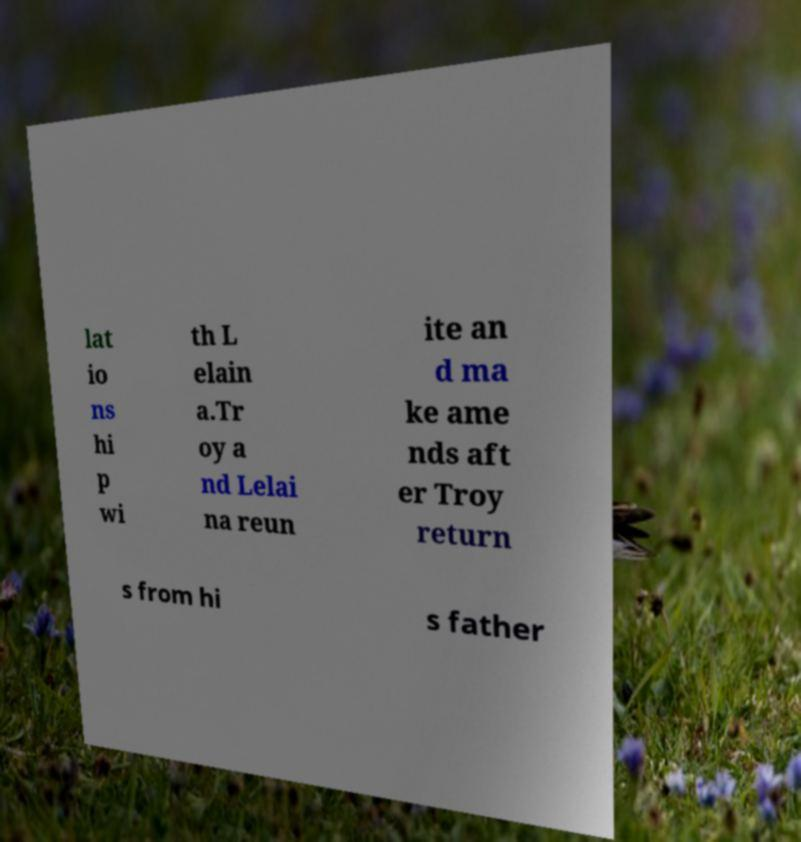What messages or text are displayed in this image? I need them in a readable, typed format. lat io ns hi p wi th L elain a.Tr oy a nd Lelai na reun ite an d ma ke ame nds aft er Troy return s from hi s father 